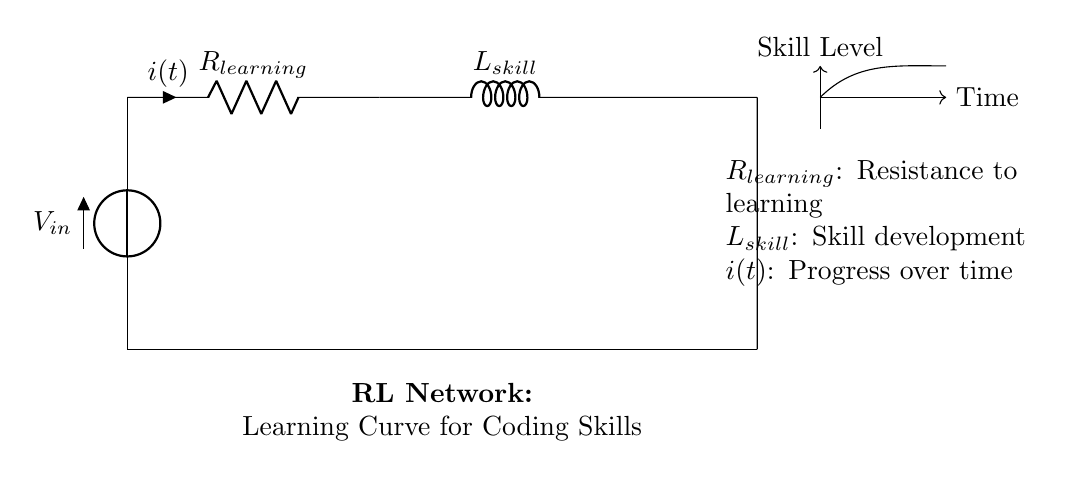What is the voltage source in this circuit? The circuit diagram shows a voltage source denoted as \( V_{in} \), which is the input voltage that drives the circuit.
Answer: V in What does \( R_{learning} \) represent in this context? \( R_{learning} \) is labeled in the circuit and represents the resistance to learning, which is a metaphor for the challenges one faces while acquiring new coding skills.
Answer: Resistance to learning What is indicated by the current \( i(t) \) in the diagram? The current \( i(t) \) indicates the progress over time in acquiring coding skills and is represented as the flow in the circuit related to learning.
Answer: Progress over time How do the components relate to skill acquisition? The circuit uses \( R_{learning} \) and \( L_{skill} \) to metaphorically depict the process of skill acquisition, where resistance represents barriers to learning and inductance represents the development of skill over time.
Answer: Resistance and skill development What type of circuit is illustrated? The circuit is a Resistor-Inductor circuit, specifically designed to simulate the learning curve for acquiring new coding skills.
Answer: Resistor-Inductor What does \( L_{skill} \) signify in the circuit? \( L_{skill} \) is labeled in the circuit and signifies the skill development aspect related to time and experience gained while learning to code.
Answer: Skill development What does the direction of the arrows represent in this diagram? The arrows indicate the direction of current flow in the circuit, which aligns with the progress of skill acquisition over time.
Answer: Direction of current flow 